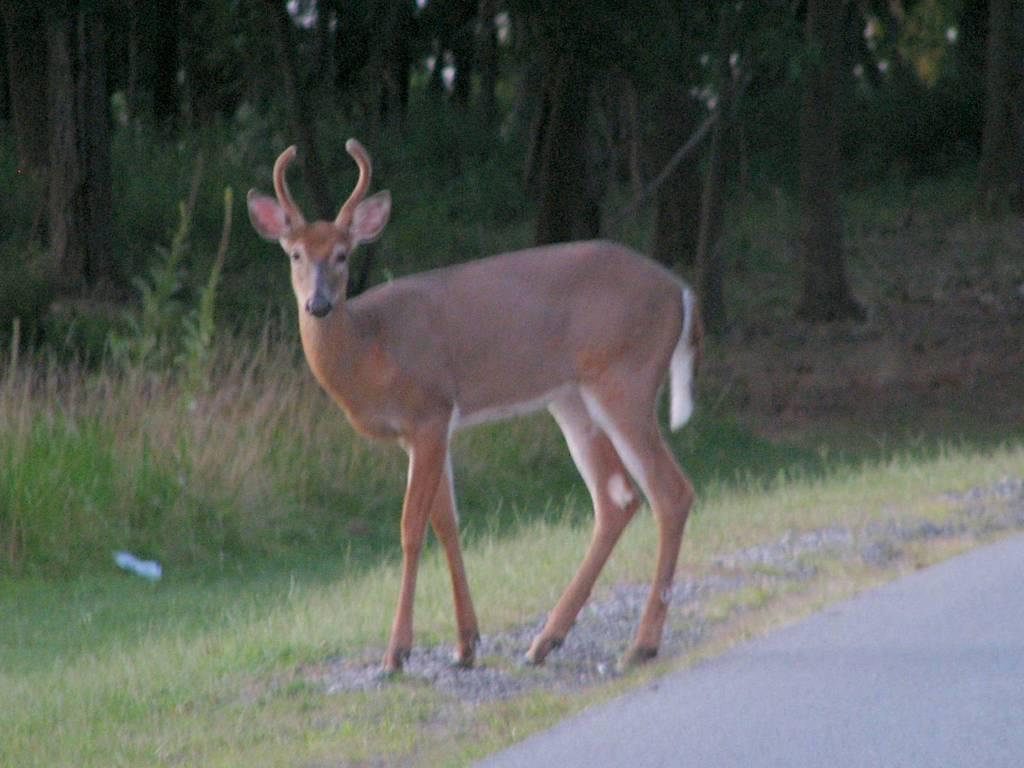What is the main feature of the image? There is a road in the image. What type of animal can be seen near the road? A deer is visible in the image. What type of vegetation is present at the bottom of the image? Grass is present at the bottom of the image. What can be seen in the distance in the image? There are trees in the background of the image. What type of cart is being pulled by the dogs in the image? There are no dogs or carts present in the image. What type of wine is being served at the event in the image? There is no event or wine present in the image. 